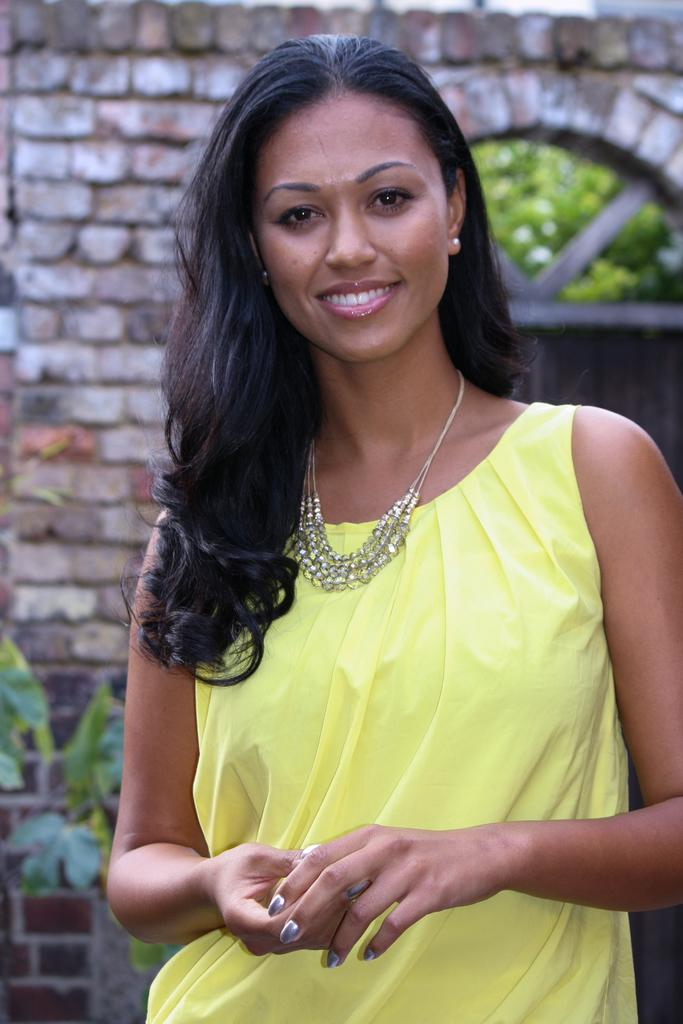What is the primary subject in the image? There is a woman standing in the image. What is behind the woman in the image? There is a brick wall behind the woman. What type of natural elements can be seen in the image? There are trees visible in the image. What type of straw is the woman holding in the image? There is no straw present in the image; the woman is not holding anything. 